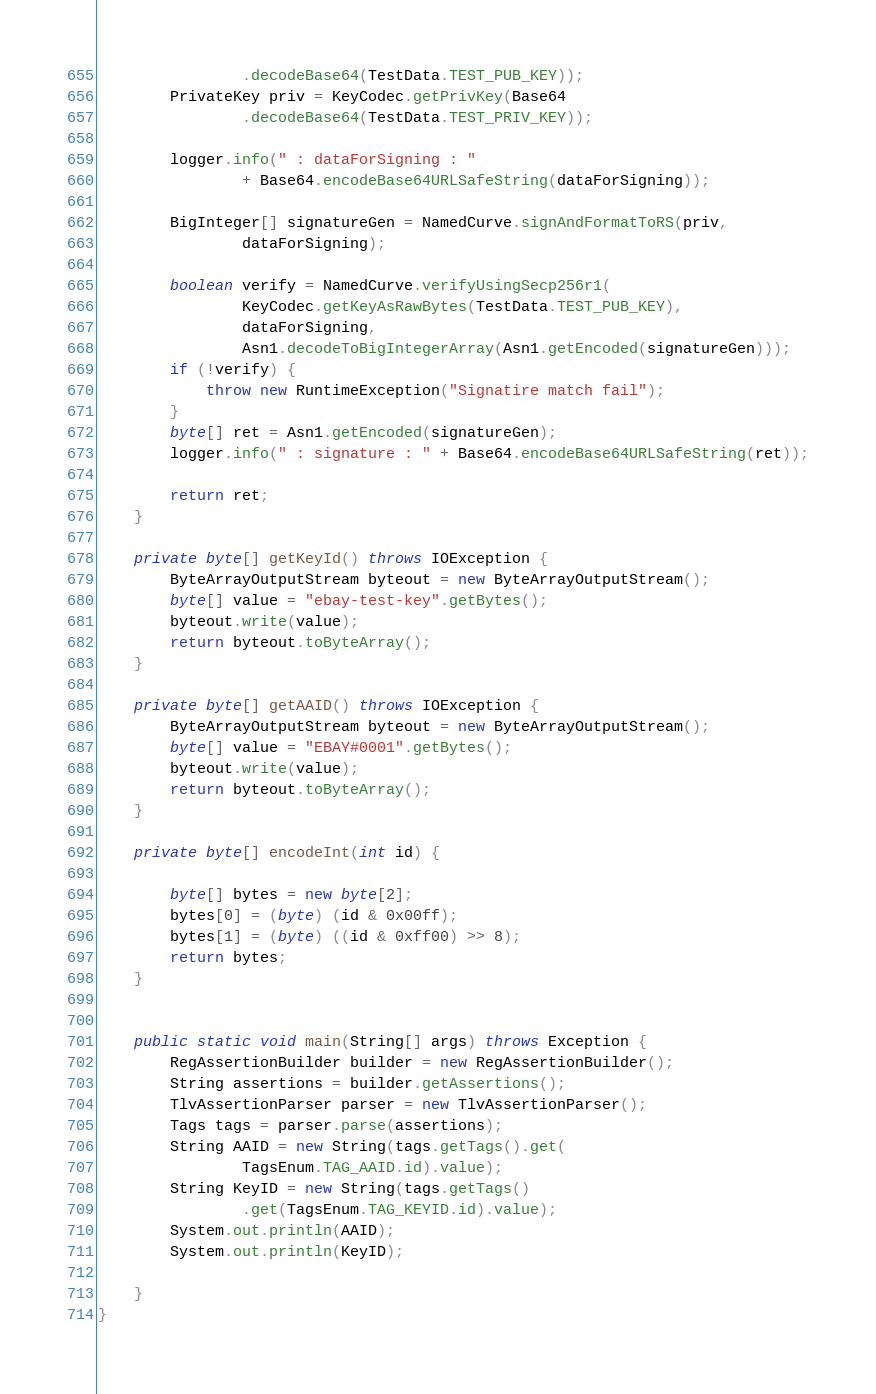<code> <loc_0><loc_0><loc_500><loc_500><_Java_>                .decodeBase64(TestData.TEST_PUB_KEY));
        PrivateKey priv = KeyCodec.getPrivKey(Base64
                .decodeBase64(TestData.TEST_PRIV_KEY));

        logger.info(" : dataForSigning : "
                + Base64.encodeBase64URLSafeString(dataForSigning));

        BigInteger[] signatureGen = NamedCurve.signAndFormatToRS(priv,
                dataForSigning);

        boolean verify = NamedCurve.verifyUsingSecp256r1(
                KeyCodec.getKeyAsRawBytes(TestData.TEST_PUB_KEY),
                dataForSigning,
                Asn1.decodeToBigIntegerArray(Asn1.getEncoded(signatureGen)));
        if (!verify) {
            throw new RuntimeException("Signatire match fail");
        }
        byte[] ret = Asn1.getEncoded(signatureGen);
        logger.info(" : signature : " + Base64.encodeBase64URLSafeString(ret));

        return ret;
    }

    private byte[] getKeyId() throws IOException {
        ByteArrayOutputStream byteout = new ByteArrayOutputStream();
        byte[] value = "ebay-test-key".getBytes();
        byteout.write(value);
        return byteout.toByteArray();
    }

    private byte[] getAAID() throws IOException {
        ByteArrayOutputStream byteout = new ByteArrayOutputStream();
        byte[] value = "EBAY#0001".getBytes();
        byteout.write(value);
        return byteout.toByteArray();
    }

    private byte[] encodeInt(int id) {

        byte[] bytes = new byte[2];
        bytes[0] = (byte) (id & 0x00ff);
        bytes[1] = (byte) ((id & 0xff00) >> 8);
        return bytes;
    }


    public static void main(String[] args) throws Exception {
        RegAssertionBuilder builder = new RegAssertionBuilder();
        String assertions = builder.getAssertions();
        TlvAssertionParser parser = new TlvAssertionParser();
        Tags tags = parser.parse(assertions);
        String AAID = new String(tags.getTags().get(
                TagsEnum.TAG_AAID.id).value);
        String KeyID = new String(tags.getTags()
                .get(TagsEnum.TAG_KEYID.id).value);
        System.out.println(AAID);
        System.out.println(KeyID);

    }
}
</code> 